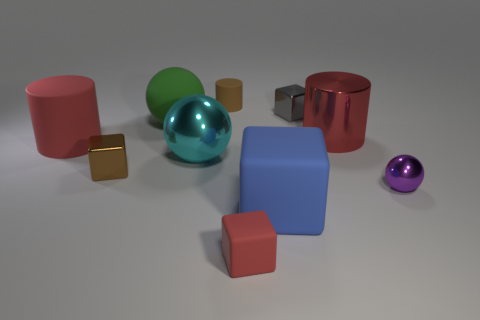There is a small metallic block to the left of the big cyan metal thing; what number of large red cylinders are behind it?
Make the answer very short. 2. What number of metallic objects are in front of the red matte cylinder and to the right of the large blue cube?
Your response must be concise. 1. What number of things are cyan spheres or big red objects left of the brown rubber thing?
Give a very brief answer. 2. What is the size of the brown thing that is the same material as the tiny ball?
Your answer should be compact. Small. What is the shape of the large rubber object behind the big red object to the right of the large red matte object?
Ensure brevity in your answer.  Sphere. What number of brown things are either tiny objects or large objects?
Offer a very short reply. 2. There is a large cylinder on the right side of the rubber cylinder in front of the red shiny cylinder; are there any shiny objects behind it?
Your answer should be compact. Yes. What shape is the large object that is the same color as the big rubber cylinder?
Provide a short and direct response. Cylinder. Are there any other things that have the same material as the purple object?
Offer a terse response. Yes. How many large objects are either red objects or purple matte things?
Your response must be concise. 2. 